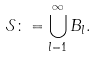<formula> <loc_0><loc_0><loc_500><loc_500>\mathcal { S } \colon = \bigcup _ { l = 1 } ^ { \infty } B _ { l } .</formula> 